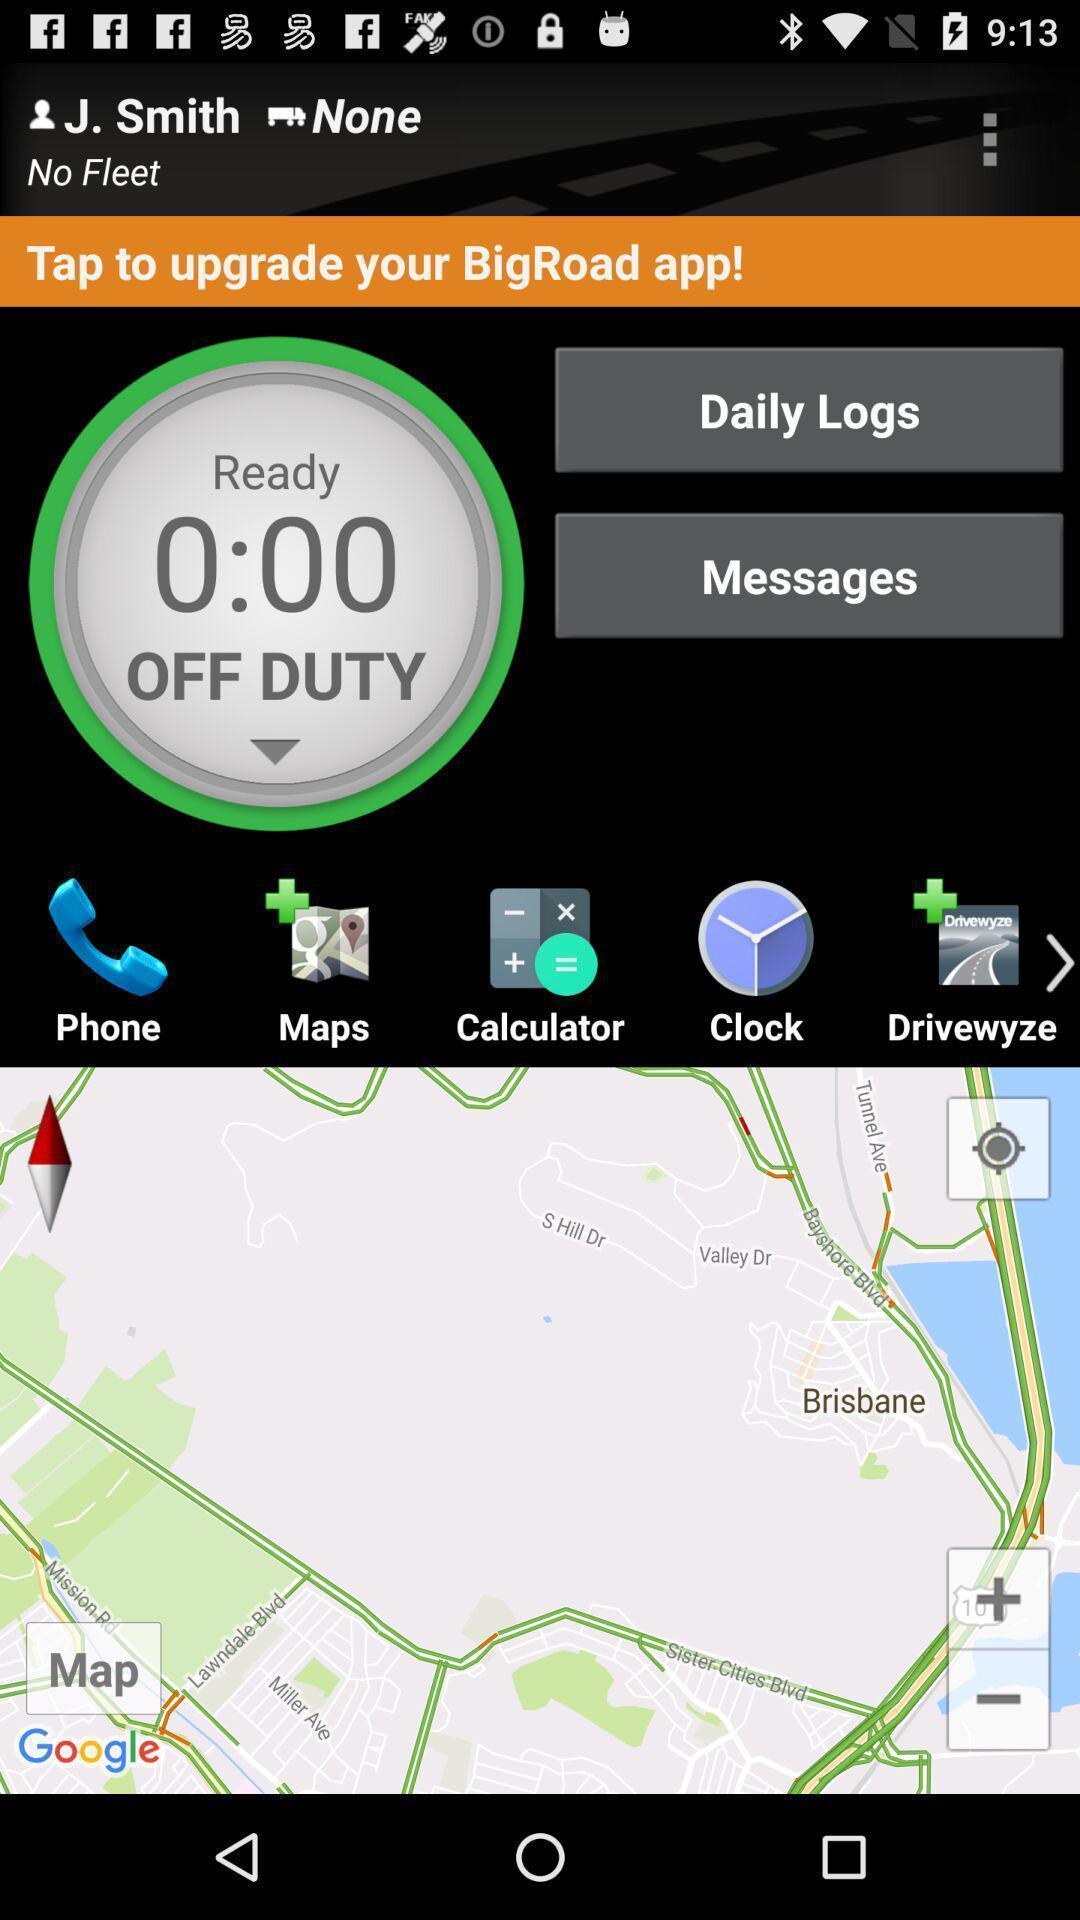Provide a detailed account of this screenshot. Screen show different options. 